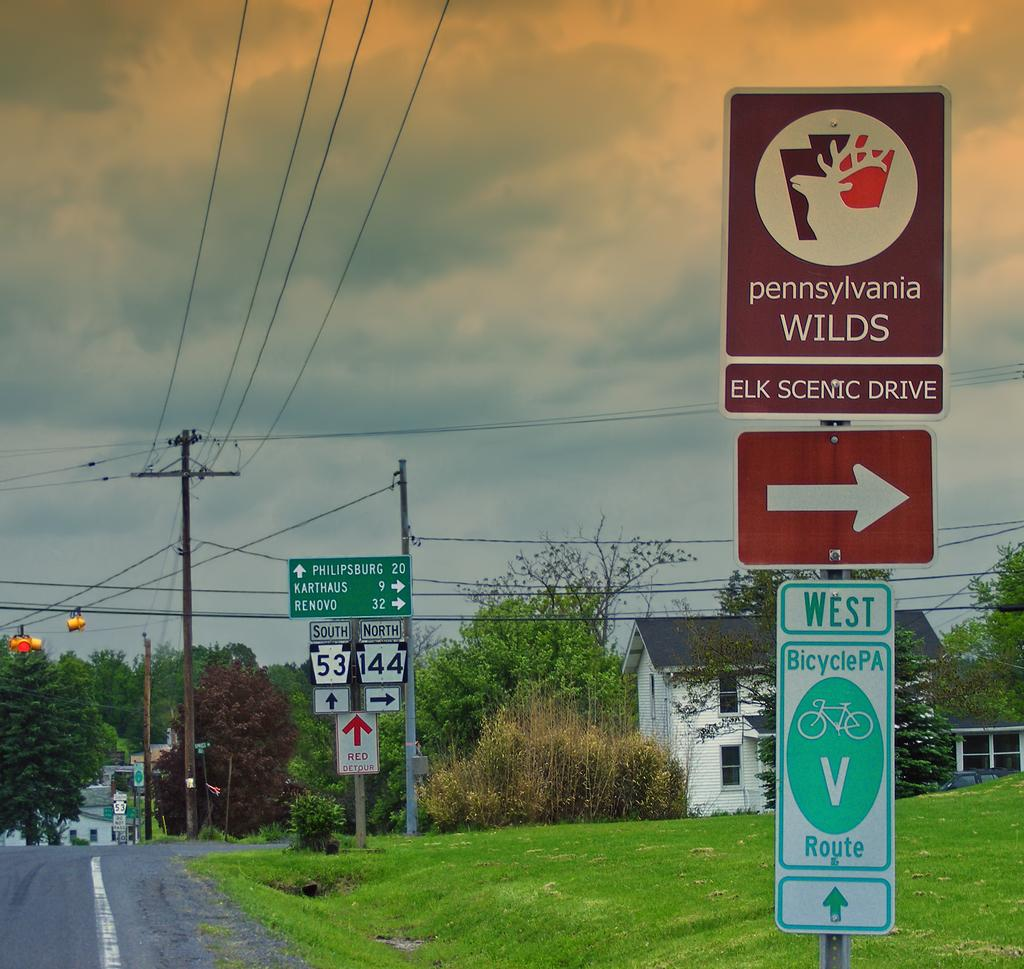Provide a one-sentence caption for the provided image. If you take a right there will be the Elk Scenic Drive. 